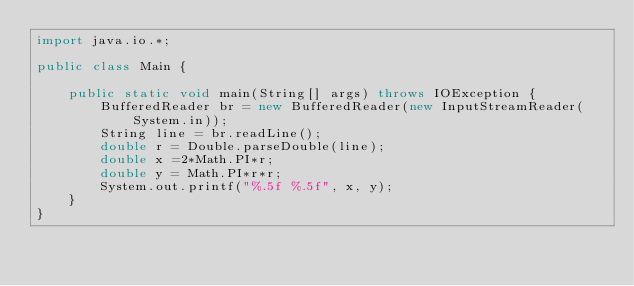Convert code to text. <code><loc_0><loc_0><loc_500><loc_500><_Java_>import java.io.*;

public class Main {

    public static void main(String[] args) throws IOException {
        BufferedReader br = new BufferedReader(new InputStreamReader(System.in));
        String line = br.readLine();
        double r = Double.parseDouble(line);
        double x =2*Math.PI*r;
        double y = Math.PI*r*r;
        System.out.printf("%.5f %.5f", x, y);
    }
}</code> 